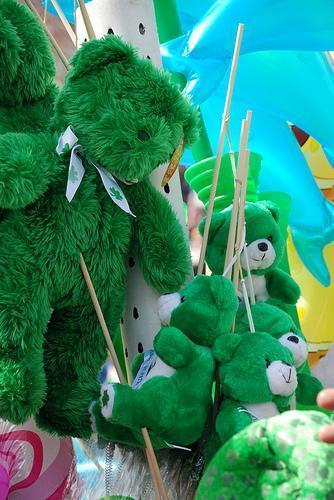How many different types of bears are there?
Give a very brief answer. 2. 